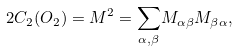<formula> <loc_0><loc_0><loc_500><loc_500>2 C _ { 2 } ( O _ { 2 } ) = M ^ { 2 } = \underset { \alpha , \beta } { \sum } M _ { \alpha \beta } M _ { \beta \alpha } ,</formula> 